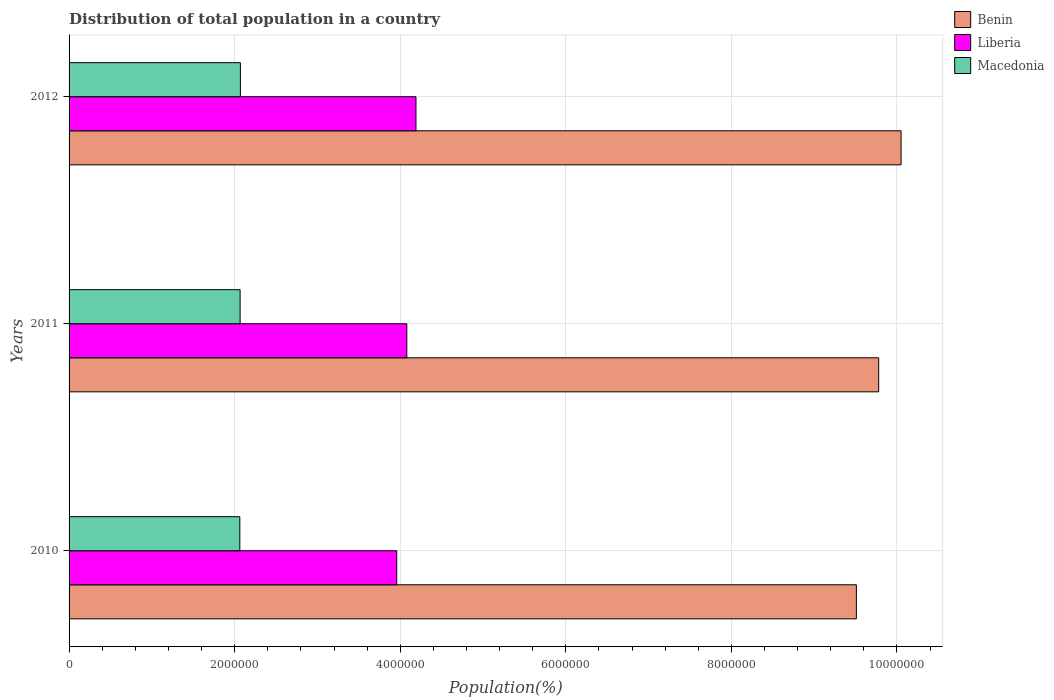Are the number of bars per tick equal to the number of legend labels?
Offer a very short reply. Yes. Are the number of bars on each tick of the Y-axis equal?
Keep it short and to the point. Yes. What is the label of the 1st group of bars from the top?
Offer a very short reply. 2012. In how many cases, is the number of bars for a given year not equal to the number of legend labels?
Your response must be concise. 0. What is the population of in Macedonia in 2011?
Your answer should be compact. 2.07e+06. Across all years, what is the maximum population of in Liberia?
Make the answer very short. 4.19e+06. Across all years, what is the minimum population of in Macedonia?
Make the answer very short. 2.06e+06. What is the total population of in Liberia in the graph?
Offer a terse response. 1.22e+07. What is the difference between the population of in Macedonia in 2011 and that in 2012?
Make the answer very short. -3382. What is the difference between the population of in Macedonia in 2011 and the population of in Liberia in 2012?
Provide a succinct answer. -2.12e+06. What is the average population of in Benin per year?
Provide a short and direct response. 9.78e+06. In the year 2011, what is the difference between the population of in Benin and population of in Macedonia?
Make the answer very short. 7.71e+06. What is the ratio of the population of in Benin in 2010 to that in 2012?
Keep it short and to the point. 0.95. Is the population of in Benin in 2011 less than that in 2012?
Provide a short and direct response. Yes. Is the difference between the population of in Benin in 2010 and 2011 greater than the difference between the population of in Macedonia in 2010 and 2011?
Your answer should be very brief. No. What is the difference between the highest and the second highest population of in Benin?
Provide a short and direct response. 2.70e+05. What is the difference between the highest and the lowest population of in Liberia?
Give a very brief answer. 2.32e+05. In how many years, is the population of in Liberia greater than the average population of in Liberia taken over all years?
Provide a short and direct response. 2. What does the 3rd bar from the top in 2010 represents?
Provide a succinct answer. Benin. What does the 1st bar from the bottom in 2010 represents?
Provide a short and direct response. Benin. Is it the case that in every year, the sum of the population of in Macedonia and population of in Benin is greater than the population of in Liberia?
Your answer should be very brief. Yes. Are the values on the major ticks of X-axis written in scientific E-notation?
Make the answer very short. No. Does the graph contain any zero values?
Give a very brief answer. No. Where does the legend appear in the graph?
Provide a succinct answer. Top right. How are the legend labels stacked?
Your response must be concise. Vertical. What is the title of the graph?
Make the answer very short. Distribution of total population in a country. Does "Netherlands" appear as one of the legend labels in the graph?
Your answer should be compact. No. What is the label or title of the X-axis?
Your answer should be very brief. Population(%). What is the Population(%) of Benin in 2010?
Your response must be concise. 9.51e+06. What is the Population(%) in Liberia in 2010?
Ensure brevity in your answer.  3.96e+06. What is the Population(%) of Macedonia in 2010?
Provide a short and direct response. 2.06e+06. What is the Population(%) in Benin in 2011?
Provide a short and direct response. 9.78e+06. What is the Population(%) in Liberia in 2011?
Your response must be concise. 4.08e+06. What is the Population(%) of Macedonia in 2011?
Ensure brevity in your answer.  2.07e+06. What is the Population(%) in Benin in 2012?
Make the answer very short. 1.00e+07. What is the Population(%) in Liberia in 2012?
Provide a short and direct response. 4.19e+06. What is the Population(%) in Macedonia in 2012?
Your response must be concise. 2.07e+06. Across all years, what is the maximum Population(%) in Benin?
Your answer should be very brief. 1.00e+07. Across all years, what is the maximum Population(%) of Liberia?
Offer a very short reply. 4.19e+06. Across all years, what is the maximum Population(%) of Macedonia?
Your response must be concise. 2.07e+06. Across all years, what is the minimum Population(%) in Benin?
Your answer should be very brief. 9.51e+06. Across all years, what is the minimum Population(%) in Liberia?
Offer a terse response. 3.96e+06. Across all years, what is the minimum Population(%) of Macedonia?
Give a very brief answer. 2.06e+06. What is the total Population(%) in Benin in the graph?
Offer a very short reply. 2.93e+07. What is the total Population(%) in Liberia in the graph?
Offer a terse response. 1.22e+07. What is the total Population(%) of Macedonia in the graph?
Your response must be concise. 6.20e+06. What is the difference between the Population(%) of Benin in 2010 and that in 2011?
Give a very brief answer. -2.70e+05. What is the difference between the Population(%) in Liberia in 2010 and that in 2011?
Your answer should be very brief. -1.22e+05. What is the difference between the Population(%) of Macedonia in 2010 and that in 2011?
Keep it short and to the point. -3445. What is the difference between the Population(%) of Benin in 2010 and that in 2012?
Make the answer very short. -5.40e+05. What is the difference between the Population(%) of Liberia in 2010 and that in 2012?
Make the answer very short. -2.32e+05. What is the difference between the Population(%) in Macedonia in 2010 and that in 2012?
Keep it short and to the point. -6827. What is the difference between the Population(%) of Benin in 2011 and that in 2012?
Provide a short and direct response. -2.70e+05. What is the difference between the Population(%) of Liberia in 2011 and that in 2012?
Make the answer very short. -1.11e+05. What is the difference between the Population(%) of Macedonia in 2011 and that in 2012?
Provide a succinct answer. -3382. What is the difference between the Population(%) in Benin in 2010 and the Population(%) in Liberia in 2011?
Give a very brief answer. 5.43e+06. What is the difference between the Population(%) of Benin in 2010 and the Population(%) of Macedonia in 2011?
Make the answer very short. 7.44e+06. What is the difference between the Population(%) of Liberia in 2010 and the Population(%) of Macedonia in 2011?
Offer a terse response. 1.89e+06. What is the difference between the Population(%) in Benin in 2010 and the Population(%) in Liberia in 2012?
Give a very brief answer. 5.32e+06. What is the difference between the Population(%) in Benin in 2010 and the Population(%) in Macedonia in 2012?
Ensure brevity in your answer.  7.44e+06. What is the difference between the Population(%) of Liberia in 2010 and the Population(%) of Macedonia in 2012?
Give a very brief answer. 1.89e+06. What is the difference between the Population(%) of Benin in 2011 and the Population(%) of Liberia in 2012?
Make the answer very short. 5.59e+06. What is the difference between the Population(%) of Benin in 2011 and the Population(%) of Macedonia in 2012?
Your answer should be very brief. 7.71e+06. What is the difference between the Population(%) in Liberia in 2011 and the Population(%) in Macedonia in 2012?
Offer a terse response. 2.01e+06. What is the average Population(%) in Benin per year?
Provide a succinct answer. 9.78e+06. What is the average Population(%) of Liberia per year?
Your answer should be compact. 4.08e+06. What is the average Population(%) of Macedonia per year?
Provide a short and direct response. 2.07e+06. In the year 2010, what is the difference between the Population(%) in Benin and Population(%) in Liberia?
Your answer should be compact. 5.55e+06. In the year 2010, what is the difference between the Population(%) in Benin and Population(%) in Macedonia?
Your response must be concise. 7.45e+06. In the year 2010, what is the difference between the Population(%) in Liberia and Population(%) in Macedonia?
Your answer should be very brief. 1.90e+06. In the year 2011, what is the difference between the Population(%) in Benin and Population(%) in Liberia?
Give a very brief answer. 5.70e+06. In the year 2011, what is the difference between the Population(%) of Benin and Population(%) of Macedonia?
Give a very brief answer. 7.71e+06. In the year 2011, what is the difference between the Population(%) of Liberia and Population(%) of Macedonia?
Offer a terse response. 2.01e+06. In the year 2012, what is the difference between the Population(%) of Benin and Population(%) of Liberia?
Offer a very short reply. 5.86e+06. In the year 2012, what is the difference between the Population(%) in Benin and Population(%) in Macedonia?
Keep it short and to the point. 7.98e+06. In the year 2012, what is the difference between the Population(%) in Liberia and Population(%) in Macedonia?
Your answer should be compact. 2.12e+06. What is the ratio of the Population(%) in Benin in 2010 to that in 2011?
Make the answer very short. 0.97. What is the ratio of the Population(%) in Liberia in 2010 to that in 2011?
Offer a very short reply. 0.97. What is the ratio of the Population(%) of Benin in 2010 to that in 2012?
Make the answer very short. 0.95. What is the ratio of the Population(%) of Liberia in 2010 to that in 2012?
Your answer should be very brief. 0.94. What is the ratio of the Population(%) of Macedonia in 2010 to that in 2012?
Offer a very short reply. 1. What is the ratio of the Population(%) of Benin in 2011 to that in 2012?
Provide a short and direct response. 0.97. What is the ratio of the Population(%) of Liberia in 2011 to that in 2012?
Offer a terse response. 0.97. What is the difference between the highest and the second highest Population(%) of Benin?
Give a very brief answer. 2.70e+05. What is the difference between the highest and the second highest Population(%) of Liberia?
Keep it short and to the point. 1.11e+05. What is the difference between the highest and the second highest Population(%) of Macedonia?
Keep it short and to the point. 3382. What is the difference between the highest and the lowest Population(%) in Benin?
Provide a succinct answer. 5.40e+05. What is the difference between the highest and the lowest Population(%) of Liberia?
Provide a succinct answer. 2.32e+05. What is the difference between the highest and the lowest Population(%) in Macedonia?
Make the answer very short. 6827. 